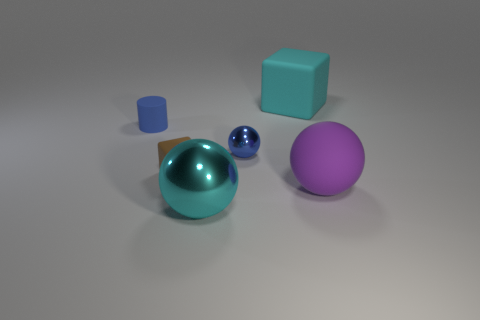There is a metallic object to the right of the cyan shiny object; is it the same color as the small cylinder?
Your answer should be compact. Yes. How many other things are there of the same color as the small matte cylinder?
Keep it short and to the point. 1. How many small things are either cyan shiny objects or yellow objects?
Offer a very short reply. 0. Are there more tiny cylinders than blue things?
Provide a short and direct response. No. Are the tiny blue cylinder and the large purple thing made of the same material?
Your answer should be compact. Yes. Are there more large cyan things that are behind the tiny cylinder than cyan cylinders?
Make the answer very short. Yes. Does the big matte block have the same color as the large metal object?
Provide a short and direct response. Yes. What number of big cyan shiny things are the same shape as the cyan matte object?
Your response must be concise. 0. What size is the cylinder that is the same material as the small brown cube?
Offer a very short reply. Small. There is a rubber thing that is both in front of the small blue cylinder and left of the cyan rubber object; what is its color?
Provide a succinct answer. Brown. 